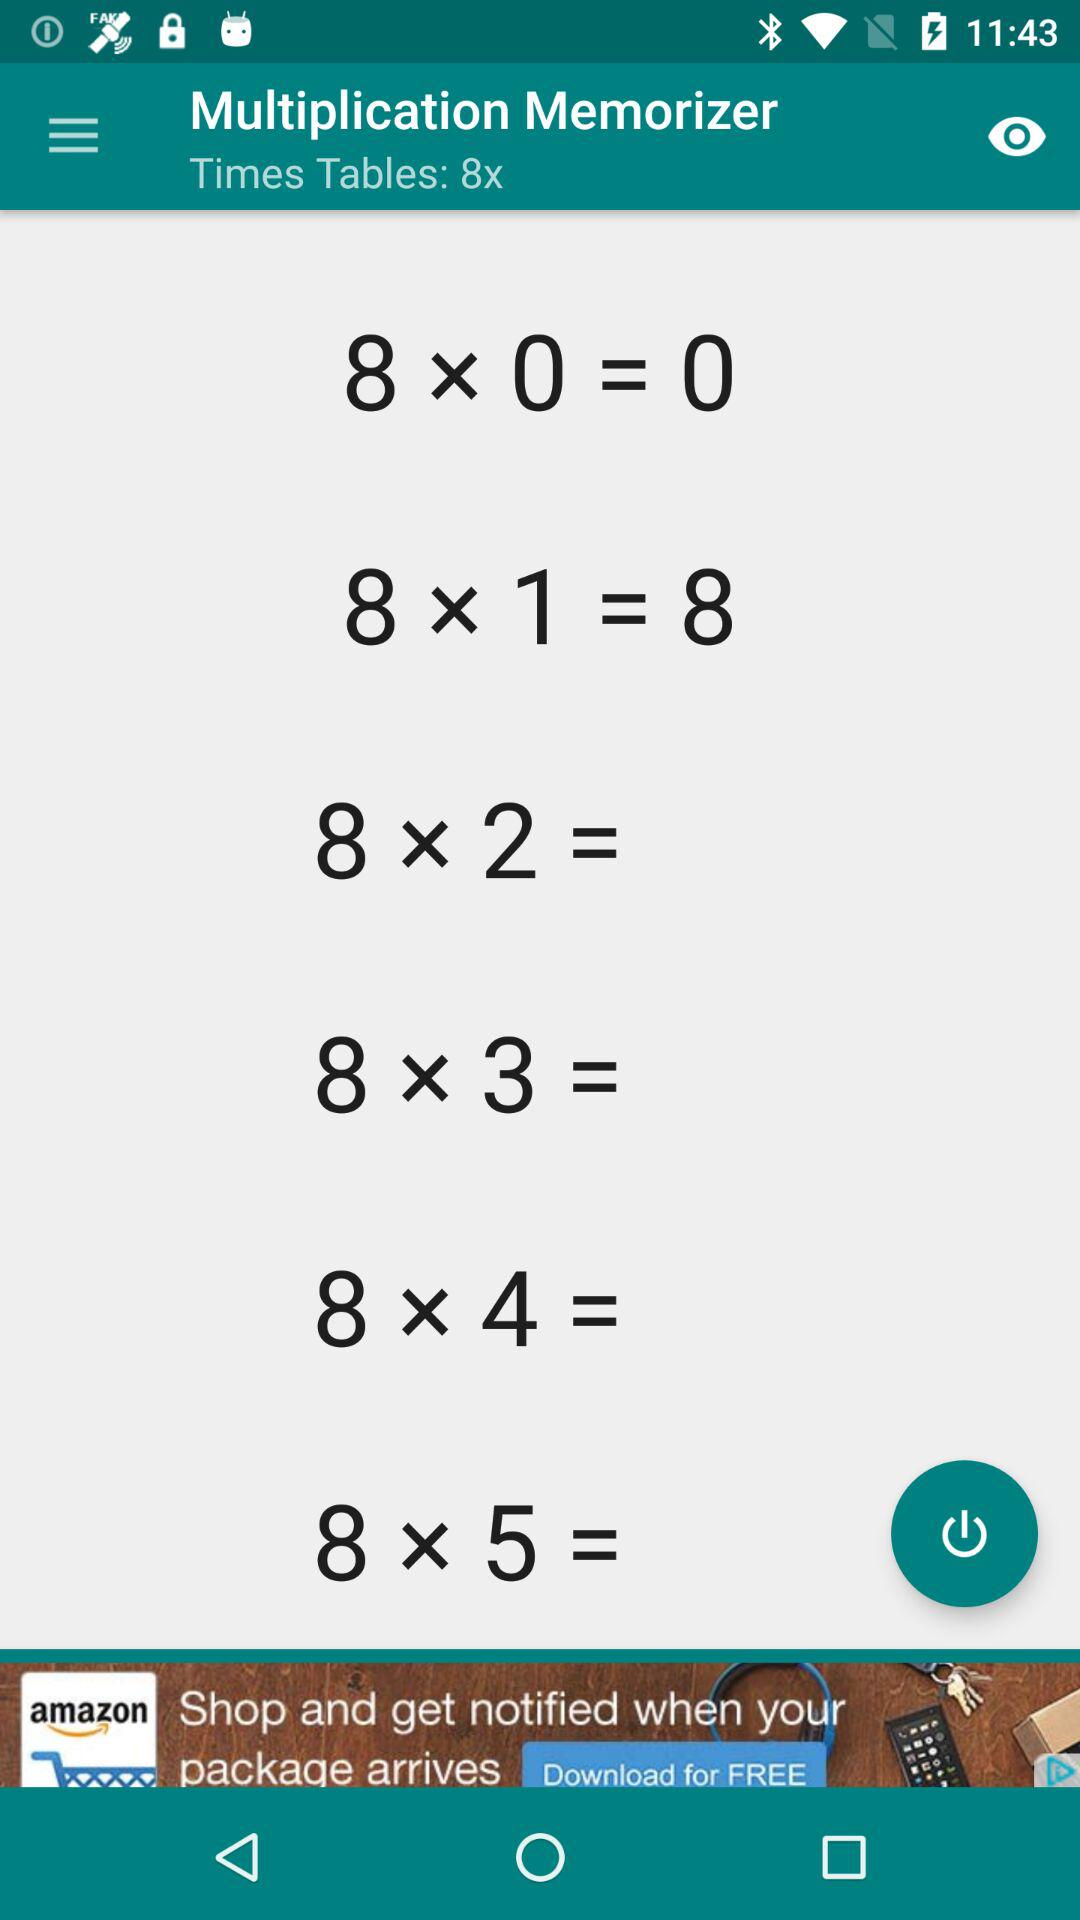What is the value of 8*1? The value of 8*1 is 8. 